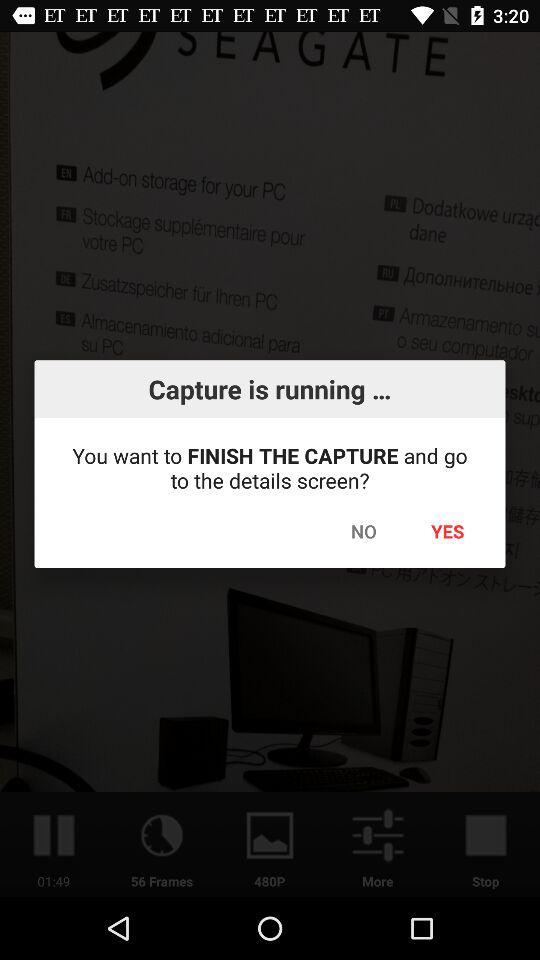What is the application name? The application name is Lapse It. 